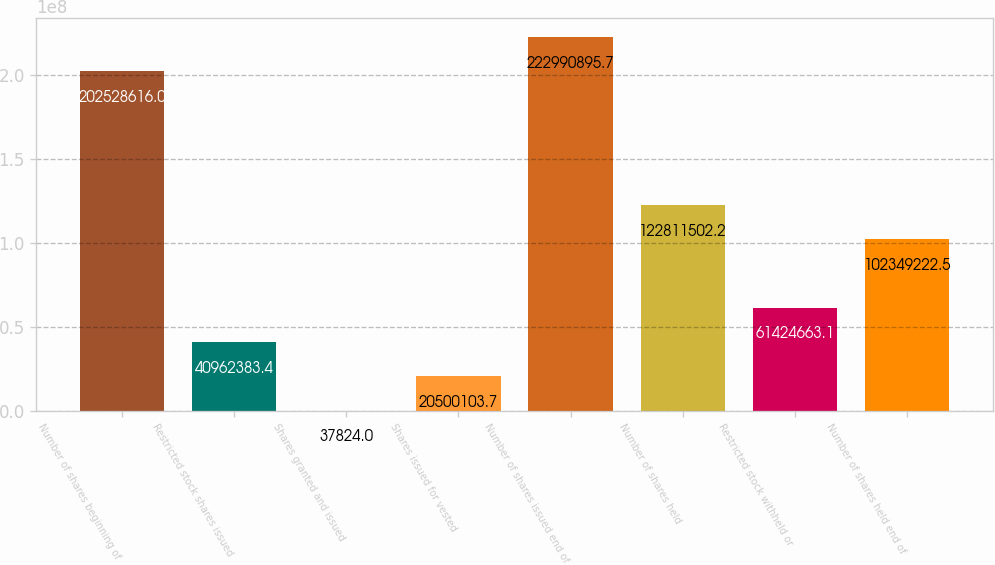<chart> <loc_0><loc_0><loc_500><loc_500><bar_chart><fcel>Number of shares beginning of<fcel>Restricted stock shares issued<fcel>Shares granted and issued<fcel>Shares issued for vested<fcel>Number of shares issued end of<fcel>Number of shares held<fcel>Restricted stock withheld or<fcel>Number of shares held end of<nl><fcel>2.02529e+08<fcel>4.09624e+07<fcel>37824<fcel>2.05001e+07<fcel>2.22991e+08<fcel>1.22812e+08<fcel>6.14247e+07<fcel>1.02349e+08<nl></chart> 